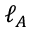Convert formula to latex. <formula><loc_0><loc_0><loc_500><loc_500>\ell _ { A }</formula> 